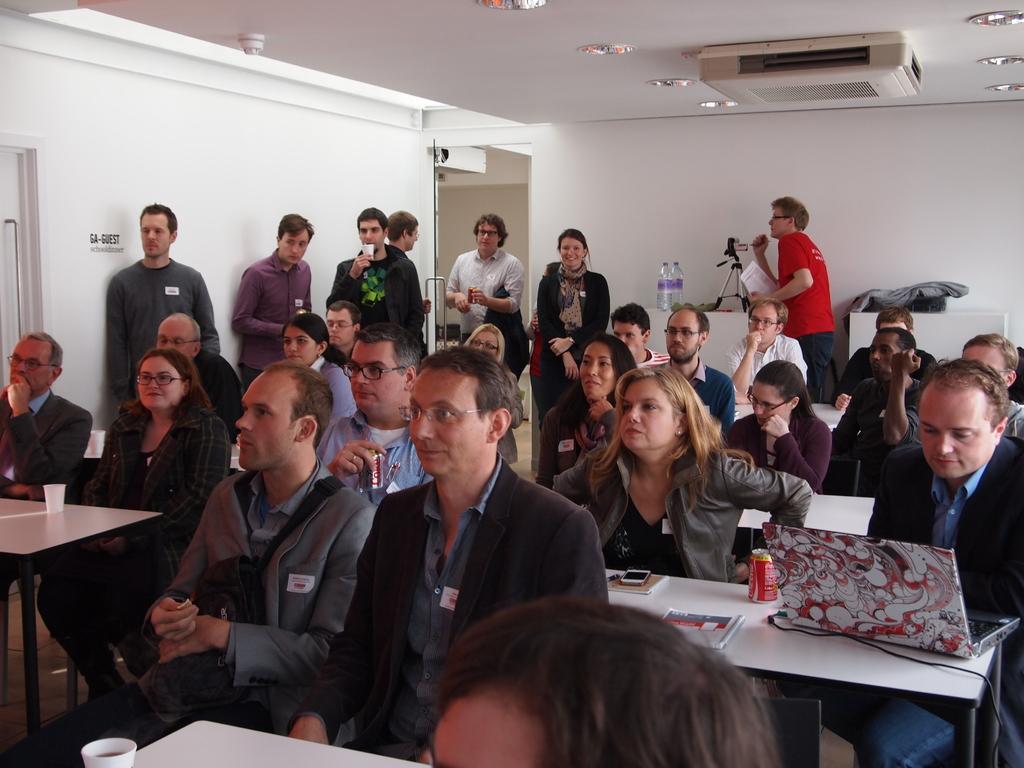Could you give a brief overview of what you see in this image? A group of people are standing on the chairs and looking at the left. Behind them there are few people standing. 